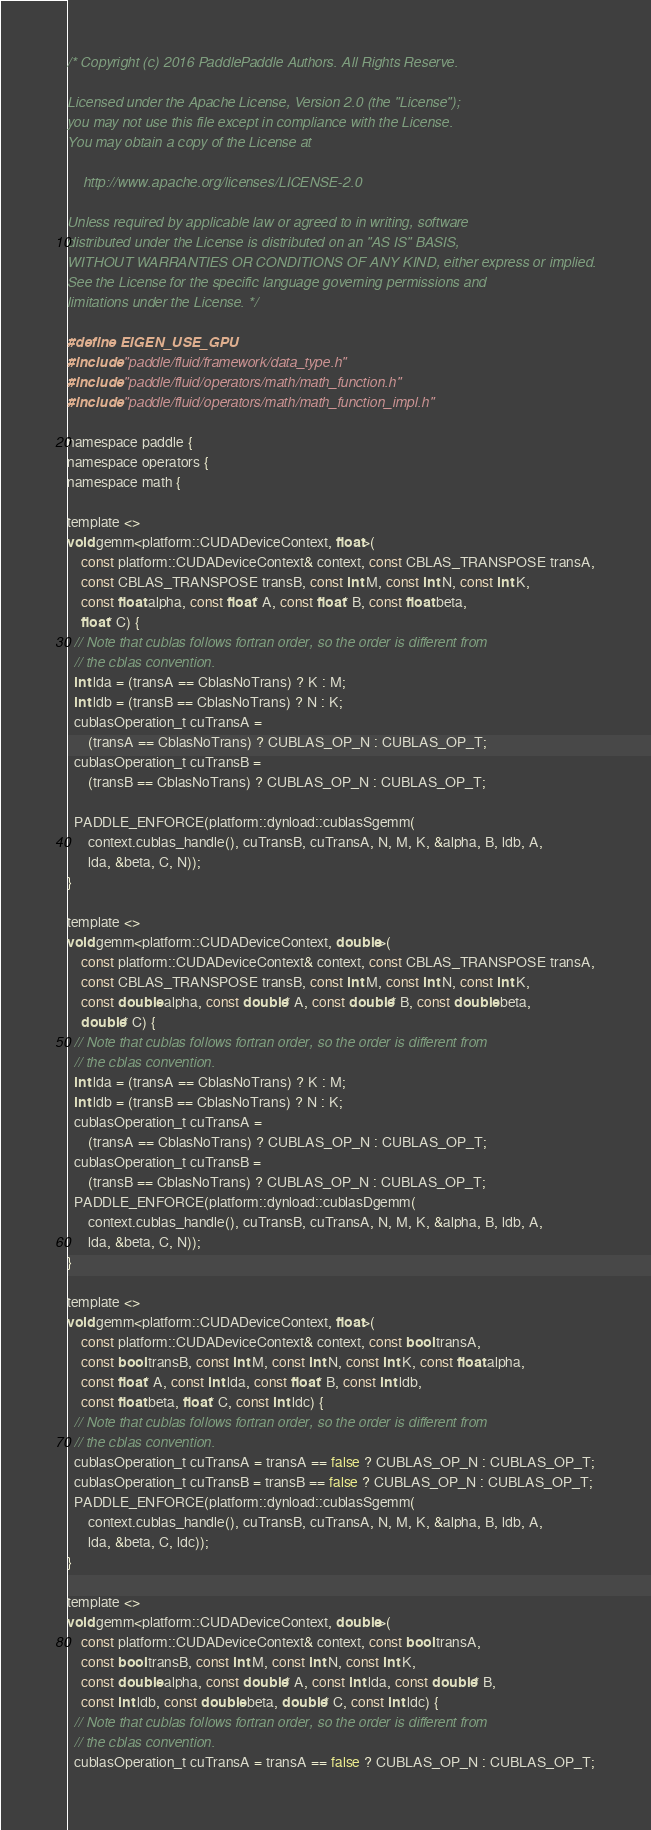<code> <loc_0><loc_0><loc_500><loc_500><_Cuda_>/* Copyright (c) 2016 PaddlePaddle Authors. All Rights Reserve.

Licensed under the Apache License, Version 2.0 (the "License");
you may not use this file except in compliance with the License.
You may obtain a copy of the License at

    http://www.apache.org/licenses/LICENSE-2.0

Unless required by applicable law or agreed to in writing, software
distributed under the License is distributed on an "AS IS" BASIS,
WITHOUT WARRANTIES OR CONDITIONS OF ANY KIND, either express or implied.
See the License for the specific language governing permissions and
limitations under the License. */

#define EIGEN_USE_GPU
#include "paddle/fluid/framework/data_type.h"
#include "paddle/fluid/operators/math/math_function.h"
#include "paddle/fluid/operators/math/math_function_impl.h"

namespace paddle {
namespace operators {
namespace math {

template <>
void gemm<platform::CUDADeviceContext, float>(
    const platform::CUDADeviceContext& context, const CBLAS_TRANSPOSE transA,
    const CBLAS_TRANSPOSE transB, const int M, const int N, const int K,
    const float alpha, const float* A, const float* B, const float beta,
    float* C) {
  // Note that cublas follows fortran order, so the order is different from
  // the cblas convention.
  int lda = (transA == CblasNoTrans) ? K : M;
  int ldb = (transB == CblasNoTrans) ? N : K;
  cublasOperation_t cuTransA =
      (transA == CblasNoTrans) ? CUBLAS_OP_N : CUBLAS_OP_T;
  cublasOperation_t cuTransB =
      (transB == CblasNoTrans) ? CUBLAS_OP_N : CUBLAS_OP_T;

  PADDLE_ENFORCE(platform::dynload::cublasSgemm(
      context.cublas_handle(), cuTransB, cuTransA, N, M, K, &alpha, B, ldb, A,
      lda, &beta, C, N));
}

template <>
void gemm<platform::CUDADeviceContext, double>(
    const platform::CUDADeviceContext& context, const CBLAS_TRANSPOSE transA,
    const CBLAS_TRANSPOSE transB, const int M, const int N, const int K,
    const double alpha, const double* A, const double* B, const double beta,
    double* C) {
  // Note that cublas follows fortran order, so the order is different from
  // the cblas convention.
  int lda = (transA == CblasNoTrans) ? K : M;
  int ldb = (transB == CblasNoTrans) ? N : K;
  cublasOperation_t cuTransA =
      (transA == CblasNoTrans) ? CUBLAS_OP_N : CUBLAS_OP_T;
  cublasOperation_t cuTransB =
      (transB == CblasNoTrans) ? CUBLAS_OP_N : CUBLAS_OP_T;
  PADDLE_ENFORCE(platform::dynload::cublasDgemm(
      context.cublas_handle(), cuTransB, cuTransA, N, M, K, &alpha, B, ldb, A,
      lda, &beta, C, N));
}

template <>
void gemm<platform::CUDADeviceContext, float>(
    const platform::CUDADeviceContext& context, const bool transA,
    const bool transB, const int M, const int N, const int K, const float alpha,
    const float* A, const int lda, const float* B, const int ldb,
    const float beta, float* C, const int ldc) {
  // Note that cublas follows fortran order, so the order is different from
  // the cblas convention.
  cublasOperation_t cuTransA = transA == false ? CUBLAS_OP_N : CUBLAS_OP_T;
  cublasOperation_t cuTransB = transB == false ? CUBLAS_OP_N : CUBLAS_OP_T;
  PADDLE_ENFORCE(platform::dynload::cublasSgemm(
      context.cublas_handle(), cuTransB, cuTransA, N, M, K, &alpha, B, ldb, A,
      lda, &beta, C, ldc));
}

template <>
void gemm<platform::CUDADeviceContext, double>(
    const platform::CUDADeviceContext& context, const bool transA,
    const bool transB, const int M, const int N, const int K,
    const double alpha, const double* A, const int lda, const double* B,
    const int ldb, const double beta, double* C, const int ldc) {
  // Note that cublas follows fortran order, so the order is different from
  // the cblas convention.
  cublasOperation_t cuTransA = transA == false ? CUBLAS_OP_N : CUBLAS_OP_T;</code> 